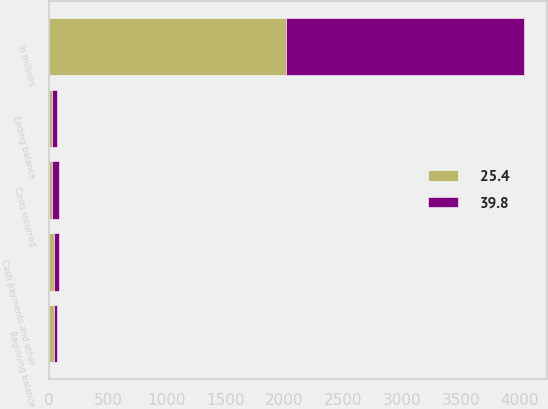Convert chart to OTSL. <chart><loc_0><loc_0><loc_500><loc_500><stacked_bar_chart><ecel><fcel>In millions<fcel>Beginning balance<fcel>Costs incurred<fcel>Cash payments and other<fcel>Ending balance<nl><fcel>39.8<fcel>2017<fcel>25.4<fcel>57.1<fcel>42.7<fcel>39.8<nl><fcel>25.4<fcel>2016<fcel>37.1<fcel>24.5<fcel>36.2<fcel>25.4<nl></chart> 